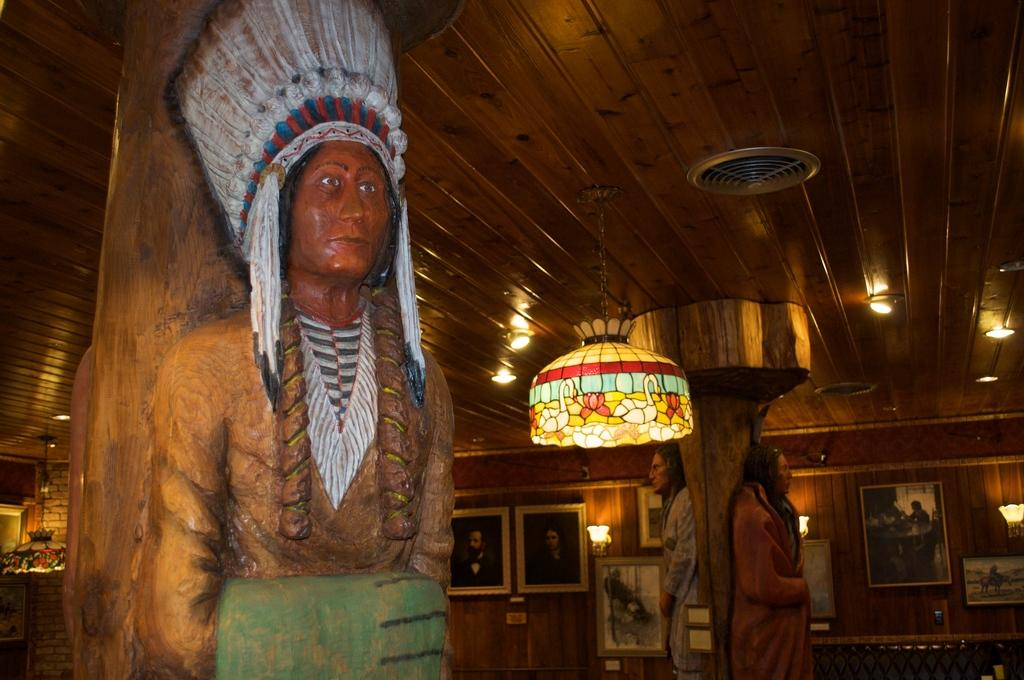What type of space is depicted in the image? The image shows the inner view of a room. What kind of objects can be seen in the room? There are wooden statues in the room. Are there any decorations on the walls? Yes, there are photo frames attached to the wall. What is the source of illumination in the room? There are lights in the room. What type of food is being served in the room in the image? There is no food visible in the image; the focus is on the wooden statues, photo frames, and lights in the room. 